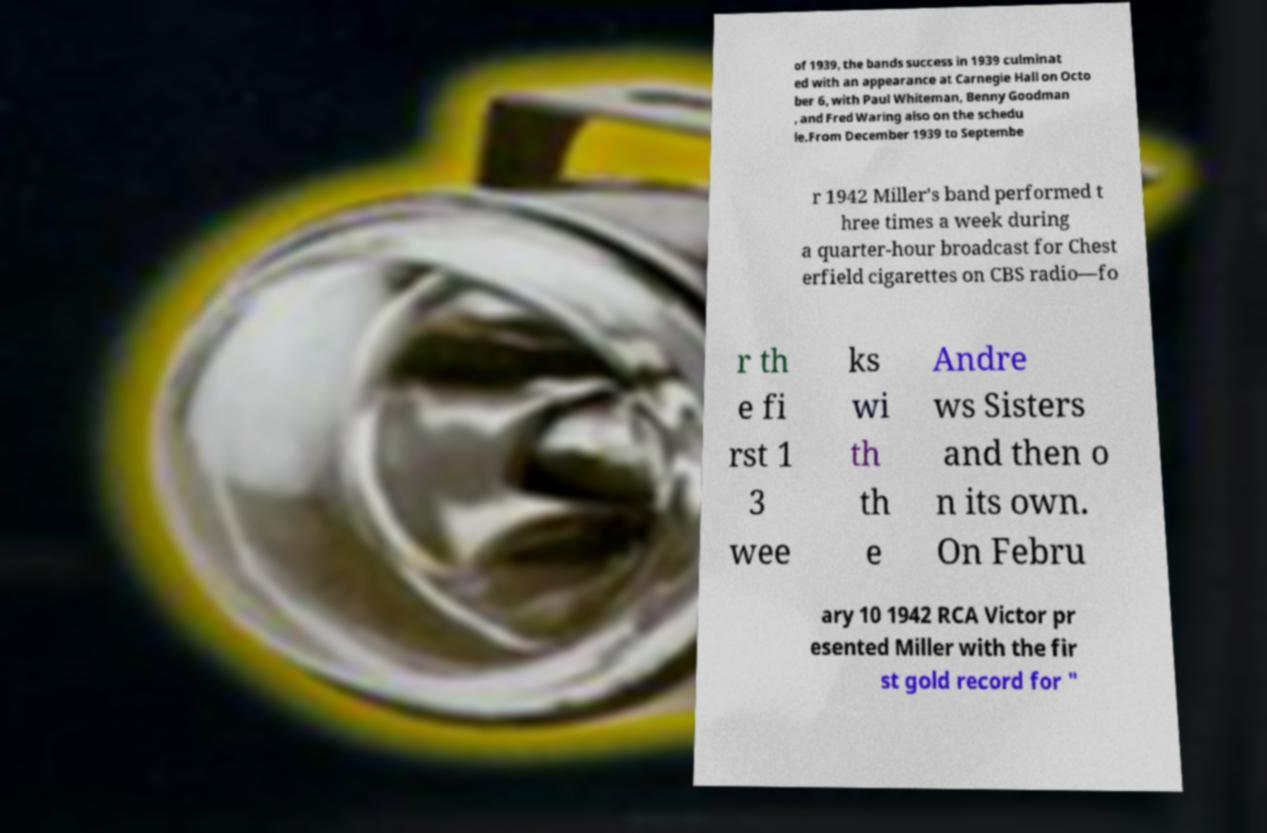I need the written content from this picture converted into text. Can you do that? of 1939, the bands success in 1939 culminat ed with an appearance at Carnegie Hall on Octo ber 6, with Paul Whiteman, Benny Goodman , and Fred Waring also on the schedu le.From December 1939 to Septembe r 1942 Miller's band performed t hree times a week during a quarter-hour broadcast for Chest erfield cigarettes on CBS radio—fo r th e fi rst 1 3 wee ks wi th th e Andre ws Sisters and then o n its own. On Febru ary 10 1942 RCA Victor pr esented Miller with the fir st gold record for " 